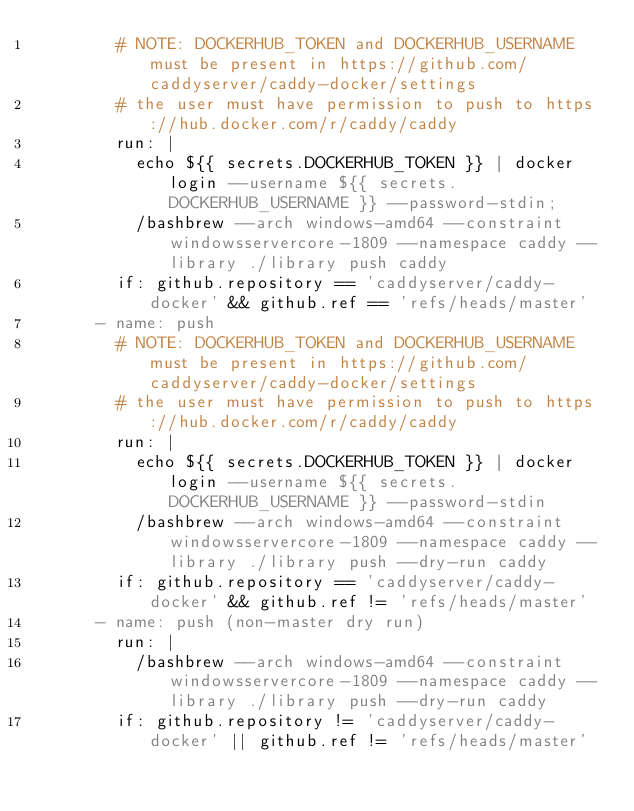<code> <loc_0><loc_0><loc_500><loc_500><_YAML_>        # NOTE: DOCKERHUB_TOKEN and DOCKERHUB_USERNAME must be present in https://github.com/caddyserver/caddy-docker/settings
        # the user must have permission to push to https://hub.docker.com/r/caddy/caddy
        run: |
          echo ${{ secrets.DOCKERHUB_TOKEN }} | docker login --username ${{ secrets.DOCKERHUB_USERNAME }} --password-stdin;
          /bashbrew --arch windows-amd64 --constraint windowsservercore-1809 --namespace caddy --library ./library push caddy
        if: github.repository == 'caddyserver/caddy-docker' && github.ref == 'refs/heads/master'
      - name: push
        # NOTE: DOCKERHUB_TOKEN and DOCKERHUB_USERNAME must be present in https://github.com/caddyserver/caddy-docker/settings
        # the user must have permission to push to https://hub.docker.com/r/caddy/caddy
        run: |
          echo ${{ secrets.DOCKERHUB_TOKEN }} | docker login --username ${{ secrets.DOCKERHUB_USERNAME }} --password-stdin
          /bashbrew --arch windows-amd64 --constraint windowsservercore-1809 --namespace caddy --library ./library push --dry-run caddy
        if: github.repository == 'caddyserver/caddy-docker' && github.ref != 'refs/heads/master'
      - name: push (non-master dry run)
        run: |
          /bashbrew --arch windows-amd64 --constraint windowsservercore-1809 --namespace caddy --library ./library push --dry-run caddy
        if: github.repository != 'caddyserver/caddy-docker' || github.ref != 'refs/heads/master'
</code> 